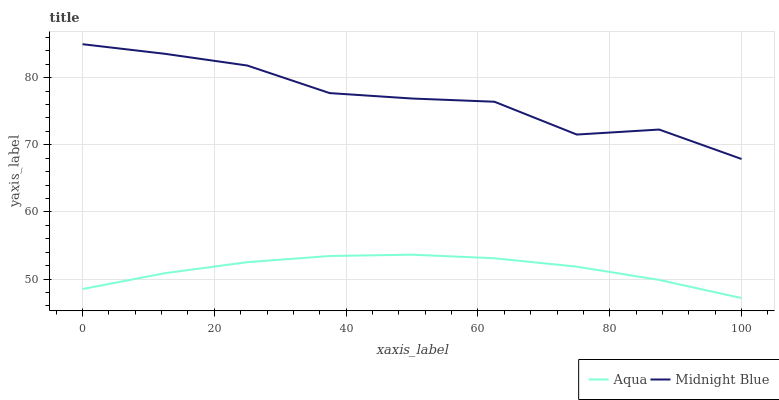Does Aqua have the minimum area under the curve?
Answer yes or no. Yes. Does Midnight Blue have the maximum area under the curve?
Answer yes or no. Yes. Does Midnight Blue have the minimum area under the curve?
Answer yes or no. No. Is Aqua the smoothest?
Answer yes or no. Yes. Is Midnight Blue the roughest?
Answer yes or no. Yes. Is Midnight Blue the smoothest?
Answer yes or no. No. Does Aqua have the lowest value?
Answer yes or no. Yes. Does Midnight Blue have the lowest value?
Answer yes or no. No. Does Midnight Blue have the highest value?
Answer yes or no. Yes. Is Aqua less than Midnight Blue?
Answer yes or no. Yes. Is Midnight Blue greater than Aqua?
Answer yes or no. Yes. Does Aqua intersect Midnight Blue?
Answer yes or no. No. 